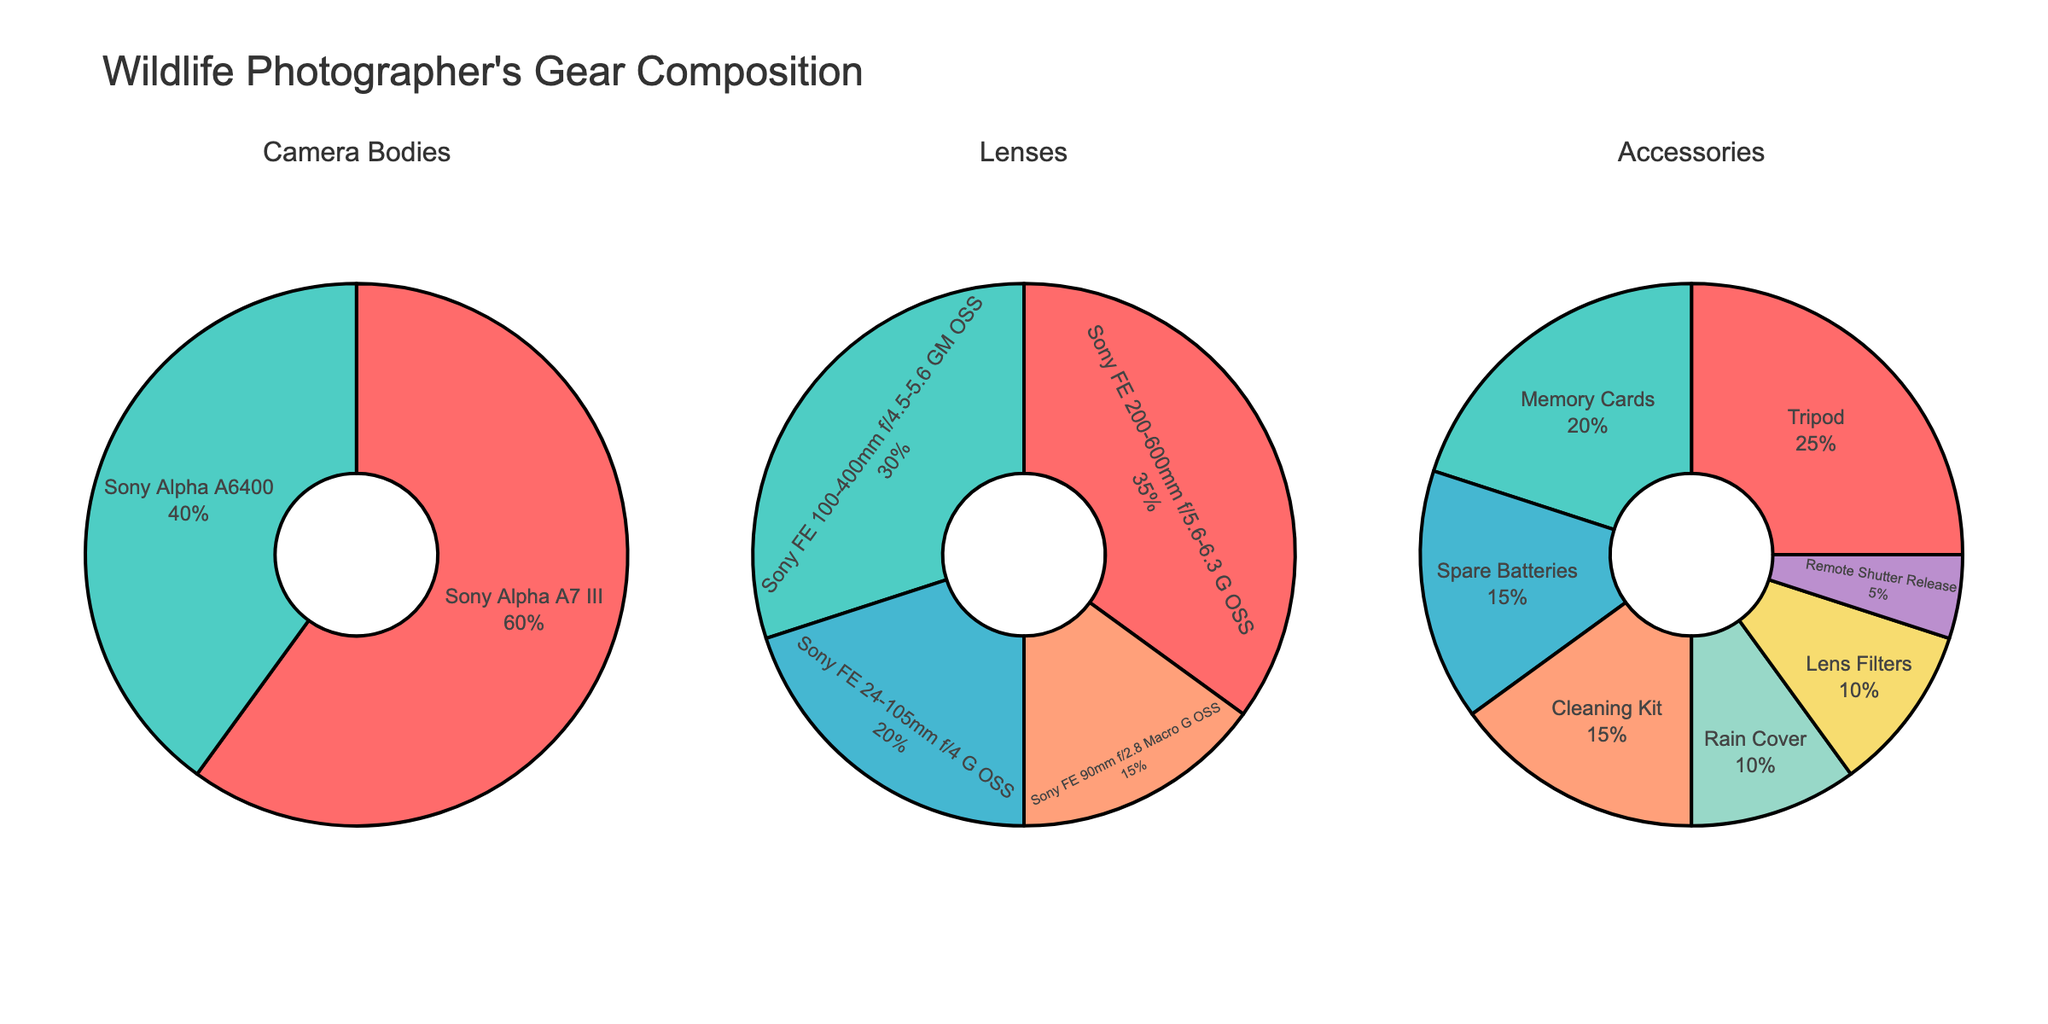Which camera body constitutes the majority of the photographer's gear bag? The pie chart for Camera Bodies shows two segments labeled Sony Alpha A7 III and Sony Alpha A6400 with their respective percentages. The Sony Alpha A7 III segment is larger and is marked with 60%, indicating it constitutes the majority.
Answer: Sony Alpha A7 III Which lens type is the least represented in the photographer's bag? The pie chart for Lenses shows four segments with their respective percentages. The Sony FE 90mm f/2.8 Macro G OSS segment is marked with 15%, which is the smallest percentage among the lenses.
Answer: Sony FE 90mm f/2.8 Macro G OSS What proportion of the accessories category is made up of the Tripod and Memory Cards combined? The pie chart for Accessories shows different segments, including Tripod (25%) and Memory Cards (20%). To find the combined proportion, add these two percentages: 25% + 20% = 45%.
Answer: 45% How does the percentage of the largest lens category compare to the smallest accessory category? The largest lens category is Sony FE 200-600mm f/5.6-6.3 G OSS at 35%, and the smallest accessory category is Remote Shutter Release at 5%. Comparing these, the largest lens category is 35% - 5% = 30% higher.
Answer: 30% higher What are the two lenses that contribute to 50% of the photographer's gear bag? The pie chart for Lenses shows four segments, and their respective percentages: Sony FE 200-600mm f/5.6-6.3 G OSS (35%), Sony FE 100-400mm f/4.5-5.6 GM OSS (30%), Sony FE 24-105mm f/4 G OSS (20%), and Sony FE 90mm f/2.8 Macro G OSS (15%). The two lenses with percentages adding up to 50% are Sony FE 200-600mm f/5.6-6.3 G OSS (35%) and Sony FE 100-400mm f/4.5-5.6 GM OSS (30%). However, combining Sony FE 24-105mm f/4 G OSS (20%) and Sony FE 90mm f/2.8 Macro G OSS (15%) gives us only 35%, which is less than 50%.
Answer: None, no two lenses add up to exactly 50% Which category has the highest diversity in terms of number of items? To determine the category with the highest diversity, count the number of items in each pie chart. The Camera Bodies chart has 2 items, the Lenses chart has 4 items, and the Accessories chart has 7 items. The category with the highest number of items is Accessories.
Answer: Accessories What percentage of the photographer's gear bag does not include camera bodies? To find the percentage that does not include camera bodies, sum the percentages of the Lenses and Accessories categories separately and then add those sums. Lenses: 35% + 30% + 20% + 15% = 100%, Accessories: 25% + 20% + 15% + 15% + 10% + 10% + 5% = 100%. Adding these two sums gives us 100% + 100% = 200%.
Answer: 200% In the lenses category, what is the percentage difference between the most common and least common lens? The pie chart for Lenses shows the Sony FE 200-600mm f/5.6-6.3 G OSS as the most common lens at 35% and the Sony FE 90mm f/2.8 Macro G OSS as the least common lens at 15%. The difference is 35% - 15% = 20%.
Answer: 20% Which accessory item has the same percentage as the smallest lens category? From the pie chart for Accessories, the items and their percentages are listed. The smallest lens category is Sony FE 90mm f/2.8 Macro G OSS at 15%. Analyzing the Accessories pie chart, the percentages include Memory Cards (20%), Spare Batteries (15%), Cleaning Kit (15%), Rain Cover (10%), Lens Filters (10%), Remote Shutter Release (5%). There are two accessory items with the same percentage of 15%: Spare Batteries and Cleaning Kit.
Answer: Spare Batteries and Cleaning Kit 